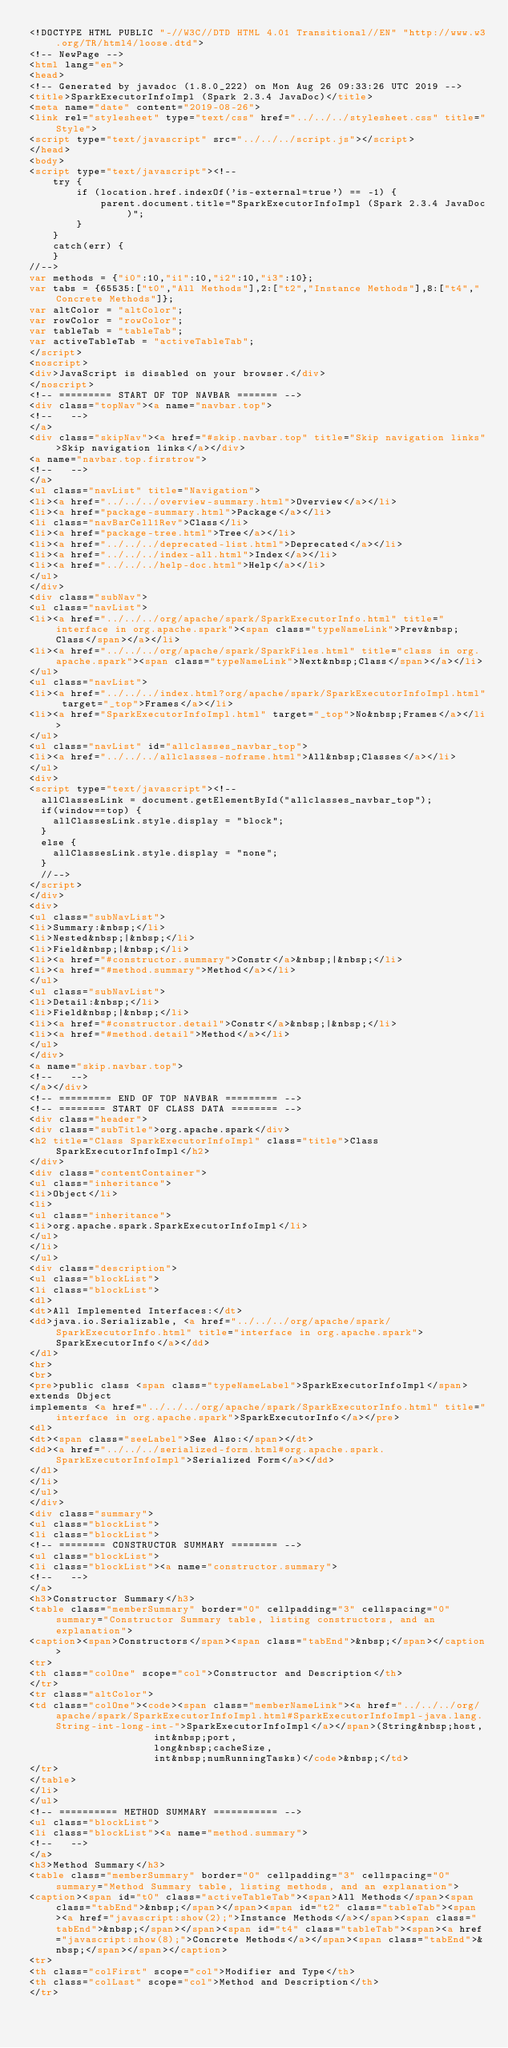Convert code to text. <code><loc_0><loc_0><loc_500><loc_500><_HTML_><!DOCTYPE HTML PUBLIC "-//W3C//DTD HTML 4.01 Transitional//EN" "http://www.w3.org/TR/html4/loose.dtd">
<!-- NewPage -->
<html lang="en">
<head>
<!-- Generated by javadoc (1.8.0_222) on Mon Aug 26 09:33:26 UTC 2019 -->
<title>SparkExecutorInfoImpl (Spark 2.3.4 JavaDoc)</title>
<meta name="date" content="2019-08-26">
<link rel="stylesheet" type="text/css" href="../../../stylesheet.css" title="Style">
<script type="text/javascript" src="../../../script.js"></script>
</head>
<body>
<script type="text/javascript"><!--
    try {
        if (location.href.indexOf('is-external=true') == -1) {
            parent.document.title="SparkExecutorInfoImpl (Spark 2.3.4 JavaDoc)";
        }
    }
    catch(err) {
    }
//-->
var methods = {"i0":10,"i1":10,"i2":10,"i3":10};
var tabs = {65535:["t0","All Methods"],2:["t2","Instance Methods"],8:["t4","Concrete Methods"]};
var altColor = "altColor";
var rowColor = "rowColor";
var tableTab = "tableTab";
var activeTableTab = "activeTableTab";
</script>
<noscript>
<div>JavaScript is disabled on your browser.</div>
</noscript>
<!-- ========= START OF TOP NAVBAR ======= -->
<div class="topNav"><a name="navbar.top">
<!--   -->
</a>
<div class="skipNav"><a href="#skip.navbar.top" title="Skip navigation links">Skip navigation links</a></div>
<a name="navbar.top.firstrow">
<!--   -->
</a>
<ul class="navList" title="Navigation">
<li><a href="../../../overview-summary.html">Overview</a></li>
<li><a href="package-summary.html">Package</a></li>
<li class="navBarCell1Rev">Class</li>
<li><a href="package-tree.html">Tree</a></li>
<li><a href="../../../deprecated-list.html">Deprecated</a></li>
<li><a href="../../../index-all.html">Index</a></li>
<li><a href="../../../help-doc.html">Help</a></li>
</ul>
</div>
<div class="subNav">
<ul class="navList">
<li><a href="../../../org/apache/spark/SparkExecutorInfo.html" title="interface in org.apache.spark"><span class="typeNameLink">Prev&nbsp;Class</span></a></li>
<li><a href="../../../org/apache/spark/SparkFiles.html" title="class in org.apache.spark"><span class="typeNameLink">Next&nbsp;Class</span></a></li>
</ul>
<ul class="navList">
<li><a href="../../../index.html?org/apache/spark/SparkExecutorInfoImpl.html" target="_top">Frames</a></li>
<li><a href="SparkExecutorInfoImpl.html" target="_top">No&nbsp;Frames</a></li>
</ul>
<ul class="navList" id="allclasses_navbar_top">
<li><a href="../../../allclasses-noframe.html">All&nbsp;Classes</a></li>
</ul>
<div>
<script type="text/javascript"><!--
  allClassesLink = document.getElementById("allclasses_navbar_top");
  if(window==top) {
    allClassesLink.style.display = "block";
  }
  else {
    allClassesLink.style.display = "none";
  }
  //-->
</script>
</div>
<div>
<ul class="subNavList">
<li>Summary:&nbsp;</li>
<li>Nested&nbsp;|&nbsp;</li>
<li>Field&nbsp;|&nbsp;</li>
<li><a href="#constructor.summary">Constr</a>&nbsp;|&nbsp;</li>
<li><a href="#method.summary">Method</a></li>
</ul>
<ul class="subNavList">
<li>Detail:&nbsp;</li>
<li>Field&nbsp;|&nbsp;</li>
<li><a href="#constructor.detail">Constr</a>&nbsp;|&nbsp;</li>
<li><a href="#method.detail">Method</a></li>
</ul>
</div>
<a name="skip.navbar.top">
<!--   -->
</a></div>
<!-- ========= END OF TOP NAVBAR ========= -->
<!-- ======== START OF CLASS DATA ======== -->
<div class="header">
<div class="subTitle">org.apache.spark</div>
<h2 title="Class SparkExecutorInfoImpl" class="title">Class SparkExecutorInfoImpl</h2>
</div>
<div class="contentContainer">
<ul class="inheritance">
<li>Object</li>
<li>
<ul class="inheritance">
<li>org.apache.spark.SparkExecutorInfoImpl</li>
</ul>
</li>
</ul>
<div class="description">
<ul class="blockList">
<li class="blockList">
<dl>
<dt>All Implemented Interfaces:</dt>
<dd>java.io.Serializable, <a href="../../../org/apache/spark/SparkExecutorInfo.html" title="interface in org.apache.spark">SparkExecutorInfo</a></dd>
</dl>
<hr>
<br>
<pre>public class <span class="typeNameLabel">SparkExecutorInfoImpl</span>
extends Object
implements <a href="../../../org/apache/spark/SparkExecutorInfo.html" title="interface in org.apache.spark">SparkExecutorInfo</a></pre>
<dl>
<dt><span class="seeLabel">See Also:</span></dt>
<dd><a href="../../../serialized-form.html#org.apache.spark.SparkExecutorInfoImpl">Serialized Form</a></dd>
</dl>
</li>
</ul>
</div>
<div class="summary">
<ul class="blockList">
<li class="blockList">
<!-- ======== CONSTRUCTOR SUMMARY ======== -->
<ul class="blockList">
<li class="blockList"><a name="constructor.summary">
<!--   -->
</a>
<h3>Constructor Summary</h3>
<table class="memberSummary" border="0" cellpadding="3" cellspacing="0" summary="Constructor Summary table, listing constructors, and an explanation">
<caption><span>Constructors</span><span class="tabEnd">&nbsp;</span></caption>
<tr>
<th class="colOne" scope="col">Constructor and Description</th>
</tr>
<tr class="altColor">
<td class="colOne"><code><span class="memberNameLink"><a href="../../../org/apache/spark/SparkExecutorInfoImpl.html#SparkExecutorInfoImpl-java.lang.String-int-long-int-">SparkExecutorInfoImpl</a></span>(String&nbsp;host,
                     int&nbsp;port,
                     long&nbsp;cacheSize,
                     int&nbsp;numRunningTasks)</code>&nbsp;</td>
</tr>
</table>
</li>
</ul>
<!-- ========== METHOD SUMMARY =========== -->
<ul class="blockList">
<li class="blockList"><a name="method.summary">
<!--   -->
</a>
<h3>Method Summary</h3>
<table class="memberSummary" border="0" cellpadding="3" cellspacing="0" summary="Method Summary table, listing methods, and an explanation">
<caption><span id="t0" class="activeTableTab"><span>All Methods</span><span class="tabEnd">&nbsp;</span></span><span id="t2" class="tableTab"><span><a href="javascript:show(2);">Instance Methods</a></span><span class="tabEnd">&nbsp;</span></span><span id="t4" class="tableTab"><span><a href="javascript:show(8);">Concrete Methods</a></span><span class="tabEnd">&nbsp;</span></span></caption>
<tr>
<th class="colFirst" scope="col">Modifier and Type</th>
<th class="colLast" scope="col">Method and Description</th>
</tr></code> 